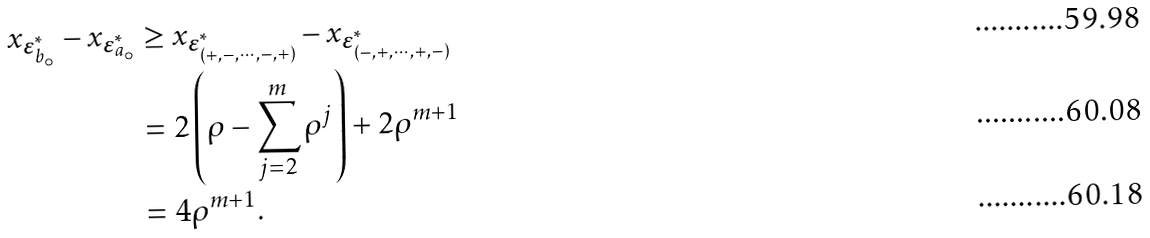Convert formula to latex. <formula><loc_0><loc_0><loc_500><loc_500>x _ { \boldsymbol \varepsilon _ { b _ { \circ } } ^ { * } } - x _ { \boldsymbol \varepsilon _ { a _ { \circ } } ^ { * } } & \geq x _ { \boldsymbol \varepsilon _ { ( + , - , \cdots , - , + ) } ^ { * } } - x _ { \boldsymbol \varepsilon _ { ( - , + , \cdots , + , - ) } ^ { * } } \\ & = 2 \left ( \rho - \sum _ { j = 2 } ^ { m } \rho ^ { j } \right ) + 2 \rho ^ { m + 1 } \\ & = 4 \rho ^ { m + 1 } .</formula> 